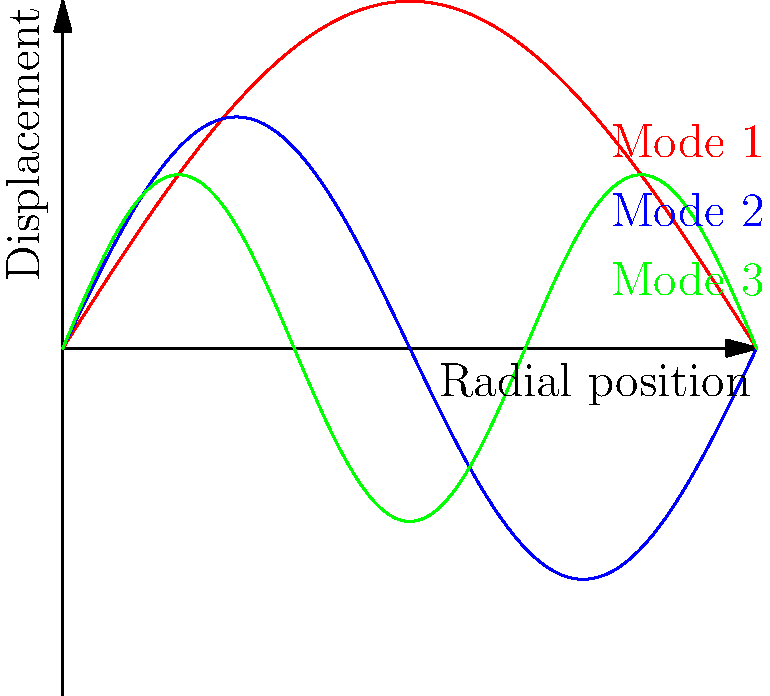In creating an authentic western soundscape for a cowboy-themed song, you're experimenting with a circular drum. The vibration modes of the drum head are shown in the graph. If the fundamental frequency (Mode 1) is 100 Hz, what would be the frequency of Mode 3, and how might this affect the timbre of your western percussion sound? To solve this problem, we need to understand the relationship between vibration modes and frequencies in a circular drum head:

1. The frequencies of vibration modes in a circular membrane are proportional to the roots of the Bessel function.

2. For the first three modes, the frequency ratios are approximately:
   Mode 1 : Mode 2 : Mode 3 = 1 : 1.59 : 2.14

3. Given that the fundamental frequency (Mode 1) is 100 Hz, we can set up a proportion:
   $$\frac{100 \text{ Hz}}{1} = \frac{x}{2.14}$$

4. Solving for x:
   $$x = 100 \text{ Hz} \times 2.14 = 214 \text{ Hz}$$

5. Therefore, the frequency of Mode 3 is 214 Hz.

6. Effect on timbre:
   - The presence of this higher frequency (214 Hz) adds brightness and complexity to the drum sound.
   - In a western soundscape, this could create a more crisp, articulate percussion sound, reminiscent of the sharp, dry acoustics often associated with desert environments.
   - The ratio between the fundamental and this overtone contributes to the unique character of the drum, potentially evoking the sound of traditional Native American drums or other percussion instruments used in western music.
Answer: 214 Hz; adds brightness and articulation to the drum sound, enhancing the western acoustic character. 